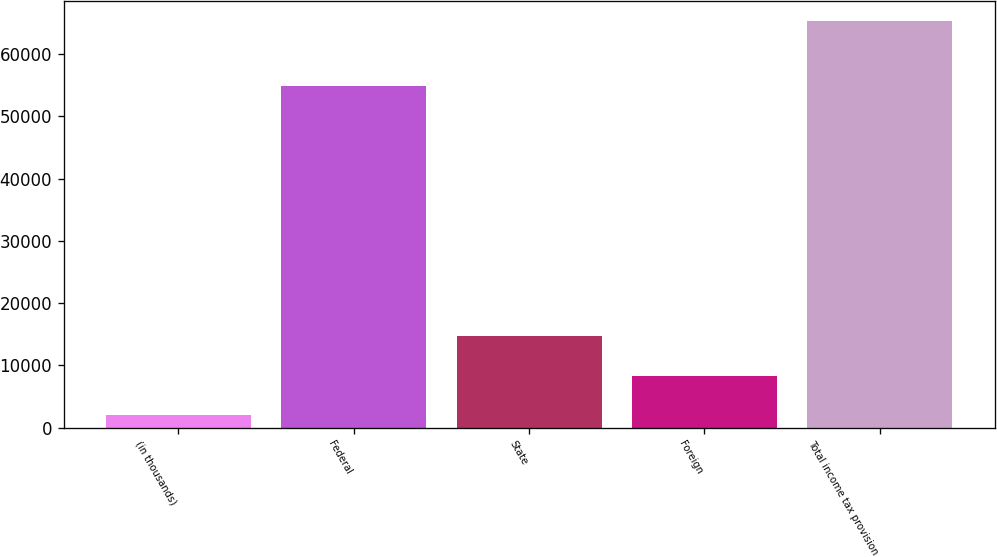Convert chart. <chart><loc_0><loc_0><loc_500><loc_500><bar_chart><fcel>(in thousands)<fcel>Federal<fcel>State<fcel>Foreign<fcel>Total income tax provision<nl><fcel>2012<fcel>54815<fcel>14671.6<fcel>8341.8<fcel>65310<nl></chart> 